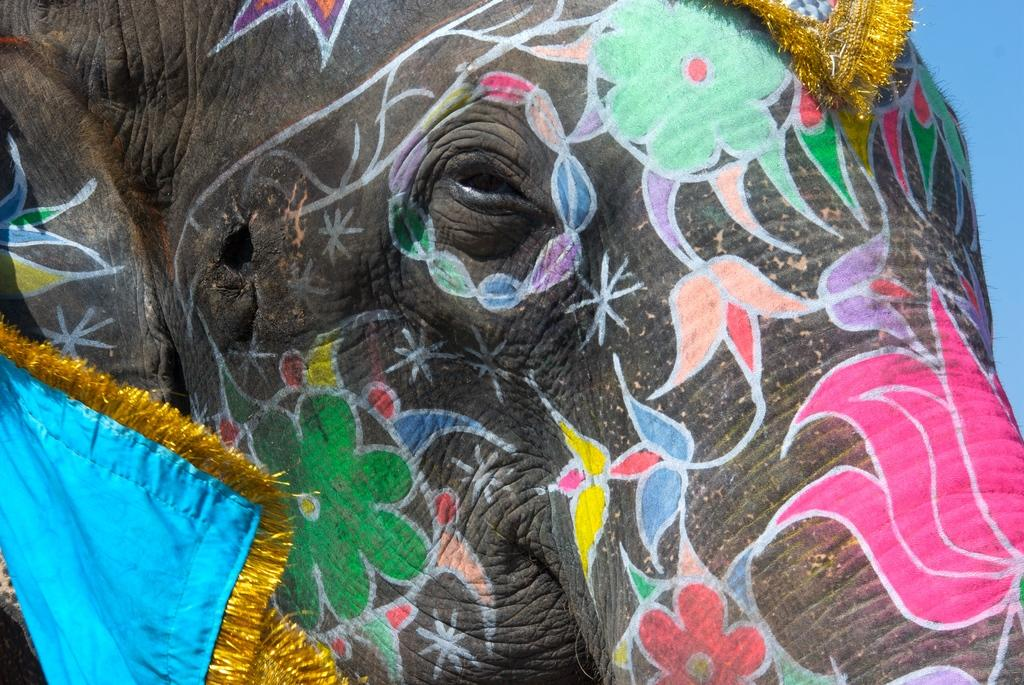What animal is the main subject of the image? There is an elephant in the image. What is unique about the appearance of the elephant? The elephant has painting and is wearing clothes. How many oranges can be seen in the image? There are no oranges present in the image. What is the elephant using to poke the other animals in the image? There is no stick or poking behavior depicted in the image. 